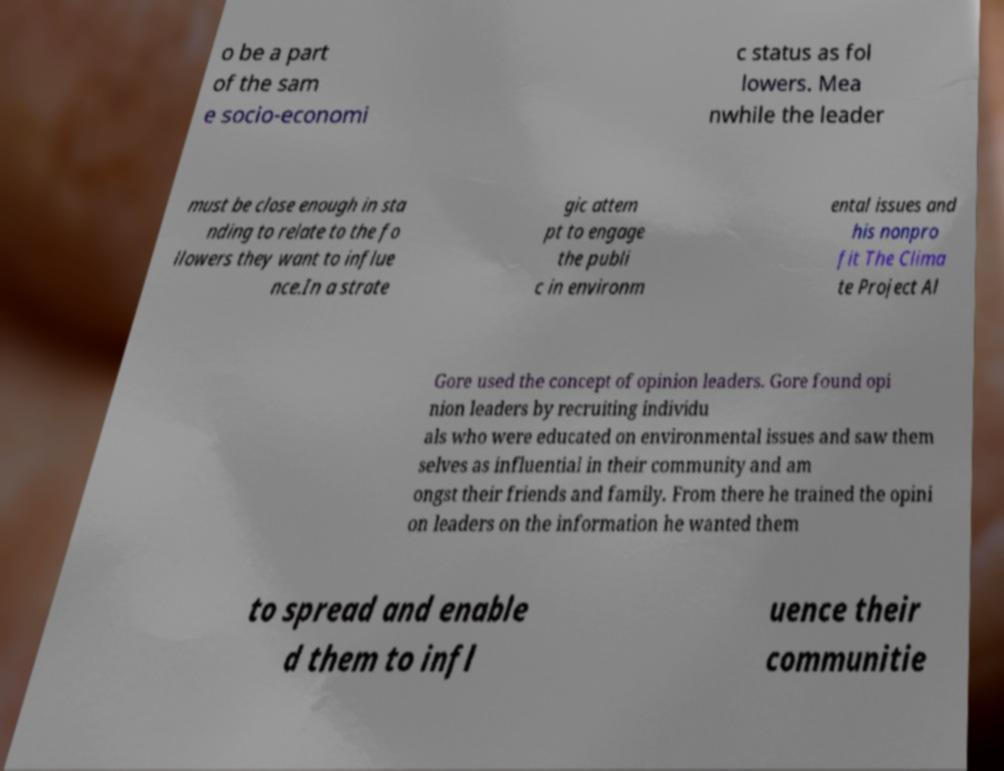For documentation purposes, I need the text within this image transcribed. Could you provide that? o be a part of the sam e socio-economi c status as fol lowers. Mea nwhile the leader must be close enough in sta nding to relate to the fo llowers they want to influe nce.In a strate gic attem pt to engage the publi c in environm ental issues and his nonpro fit The Clima te Project Al Gore used the concept of opinion leaders. Gore found opi nion leaders by recruiting individu als who were educated on environmental issues and saw them selves as influential in their community and am ongst their friends and family. From there he trained the opini on leaders on the information he wanted them to spread and enable d them to infl uence their communitie 